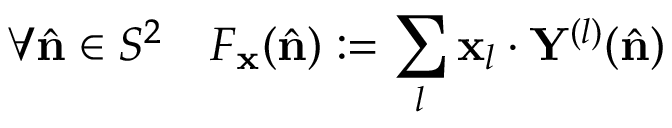<formula> <loc_0><loc_0><loc_500><loc_500>\forall \hat { n } \in S ^ { 2 } \quad F _ { x } ( \hat { n } ) \colon = \sum _ { l } x _ { l } \cdot Y ^ { ( l ) } ( \hat { n } )</formula> 